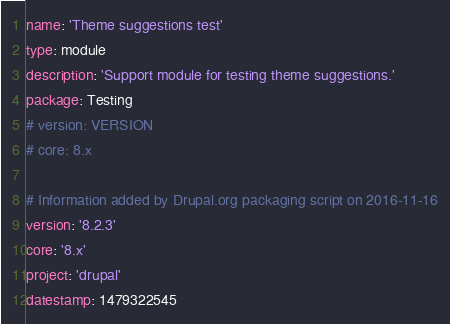Convert code to text. <code><loc_0><loc_0><loc_500><loc_500><_YAML_>name: 'Theme suggestions test'
type: module
description: 'Support module for testing theme suggestions.'
package: Testing
# version: VERSION
# core: 8.x

# Information added by Drupal.org packaging script on 2016-11-16
version: '8.2.3'
core: '8.x'
project: 'drupal'
datestamp: 1479322545
</code> 